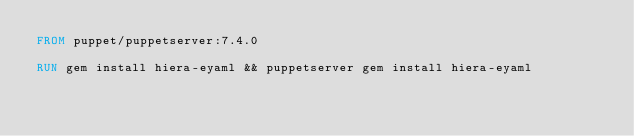<code> <loc_0><loc_0><loc_500><loc_500><_Dockerfile_>FROM puppet/puppetserver:7.4.0

RUN gem install hiera-eyaml && puppetserver gem install hiera-eyaml
</code> 